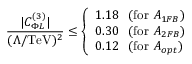<formula> <loc_0><loc_0><loc_500><loc_500>\frac { | C _ { \Phi L } ^ { ( 3 ) } | } { ( \Lambda / T e V ) ^ { 2 } } \leq \left \{ \begin{array} { l l } { { 1 . 1 8 ( f o r A _ { 1 F B } ) } } \\ { { 0 . 3 0 ( f o r A _ { 2 F B } ) } } \\ { { 0 . 1 2 ( f o r A _ { o p t } ) } } \end{array}</formula> 